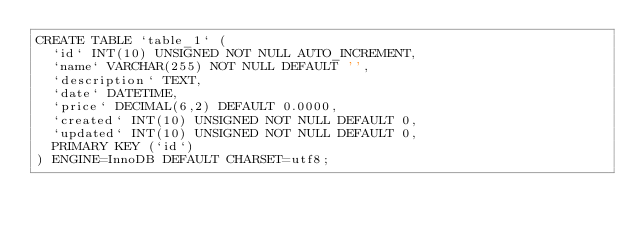<code> <loc_0><loc_0><loc_500><loc_500><_SQL_>CREATE TABLE `table_1` (
  `id` INT(10) UNSIGNED NOT NULL AUTO_INCREMENT,
  `name` VARCHAR(255) NOT NULL DEFAULT '',
  `description` TEXT,
  `date` DATETIME,
  `price` DECIMAL(6,2) DEFAULT 0.0000,
  `created` INT(10) UNSIGNED NOT NULL DEFAULT 0,
  `updated` INT(10) UNSIGNED NOT NULL DEFAULT 0,
  PRIMARY KEY (`id`)
) ENGINE=InnoDB DEFAULT CHARSET=utf8;
</code> 